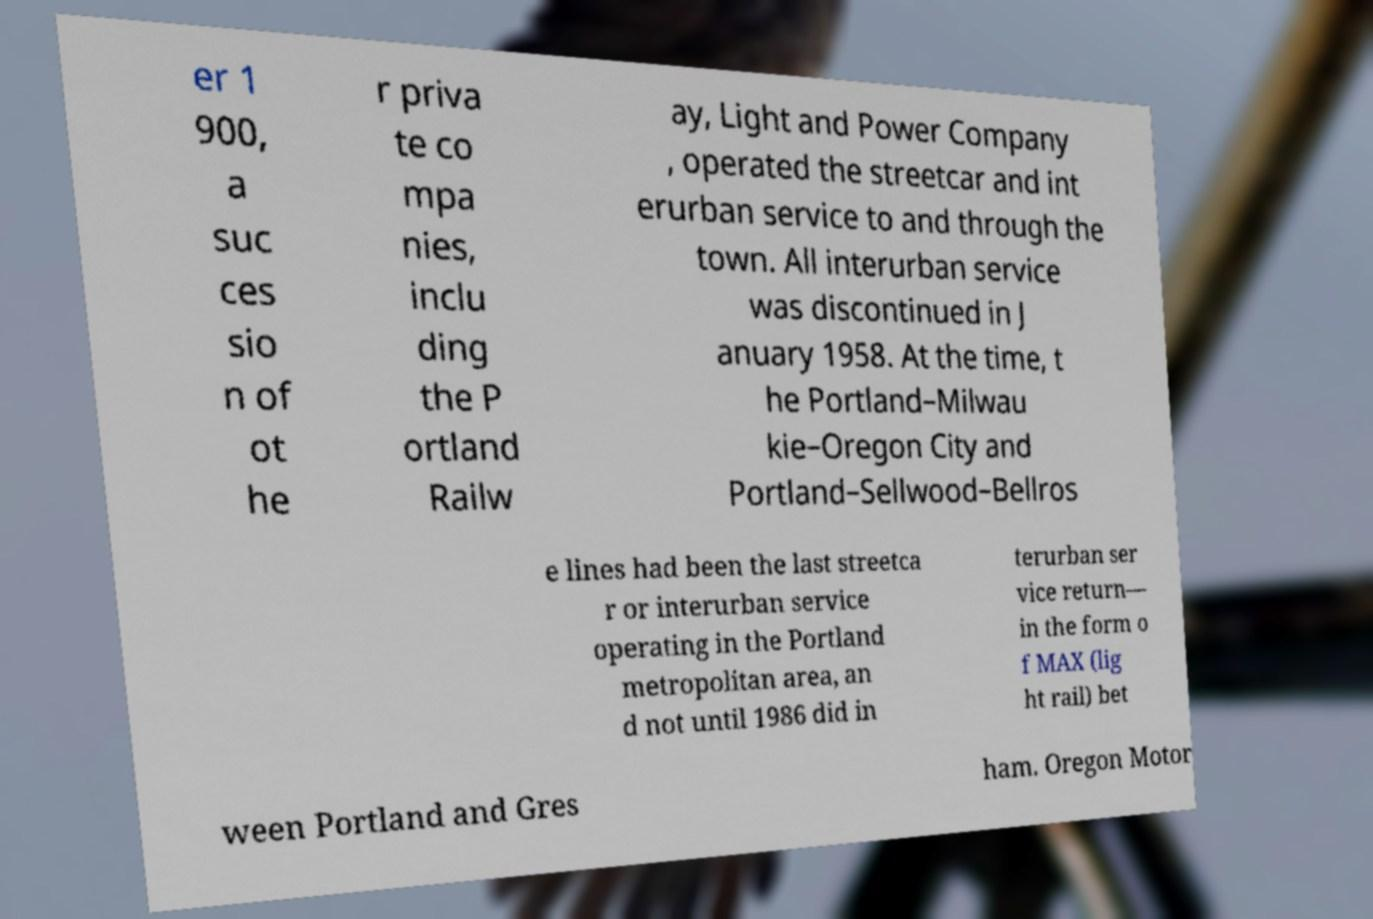Can you read and provide the text displayed in the image?This photo seems to have some interesting text. Can you extract and type it out for me? er 1 900, a suc ces sio n of ot he r priva te co mpa nies, inclu ding the P ortland Railw ay, Light and Power Company , operated the streetcar and int erurban service to and through the town. All interurban service was discontinued in J anuary 1958. At the time, t he Portland–Milwau kie–Oregon City and Portland–Sellwood–Bellros e lines had been the last streetca r or interurban service operating in the Portland metropolitan area, an d not until 1986 did in terurban ser vice return— in the form o f MAX (lig ht rail) bet ween Portland and Gres ham. Oregon Motor 